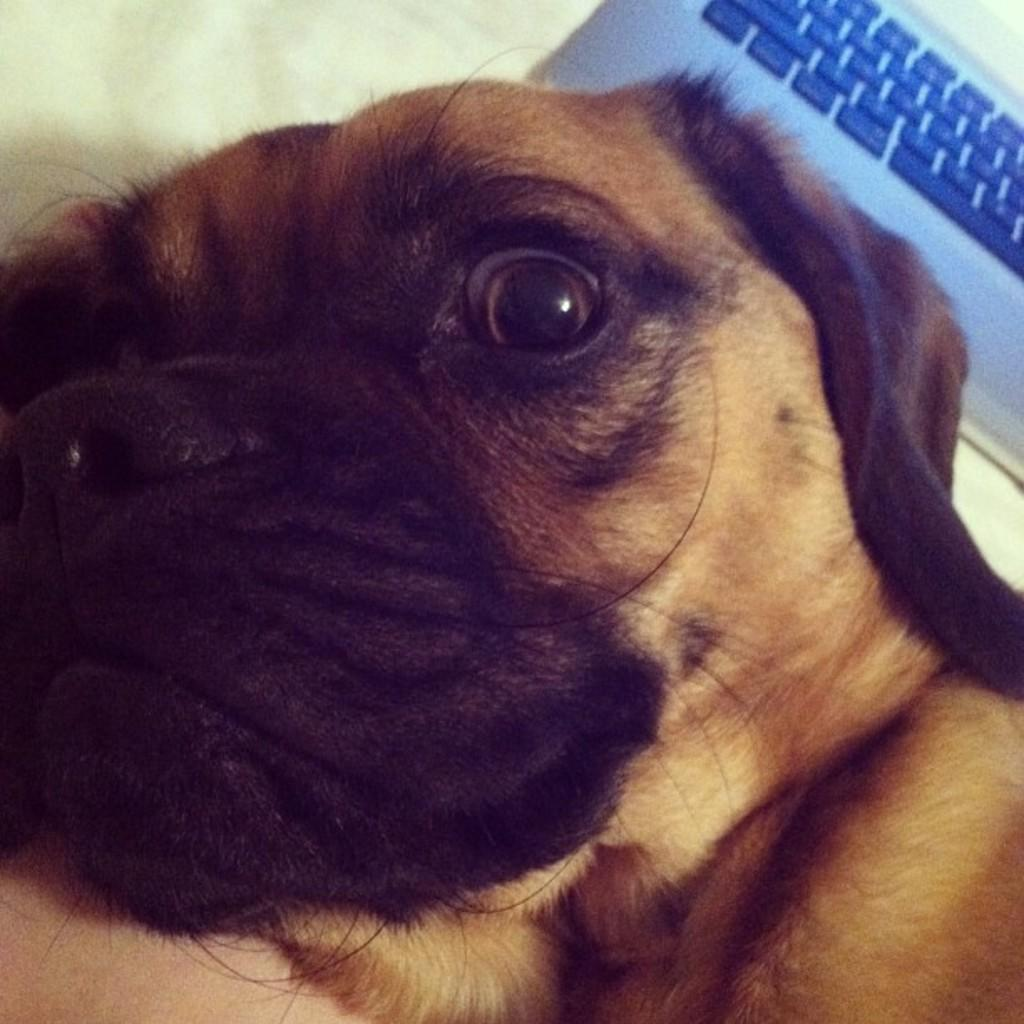What is the main subject in the middle of the image? There is a dog in the middle of the image. What object can be seen in the background of the image? There is a laptop in the background of the image. What color is the background of the image? The background is white in color. What type of stem can be seen growing from the dog's head in the image? There is no stem growing from the dog's head in the image. How much dirt is visible on the dog's paws in the image? There is no dirt visible on the dog's paws in the image. 